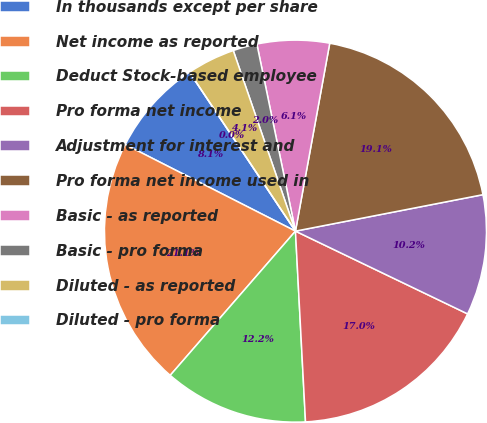<chart> <loc_0><loc_0><loc_500><loc_500><pie_chart><fcel>In thousands except per share<fcel>Net income as reported<fcel>Deduct Stock-based employee<fcel>Pro forma net income<fcel>Adjustment for interest and<fcel>Pro forma net income used in<fcel>Basic - as reported<fcel>Basic - pro forma<fcel>Diluted - as reported<fcel>Diluted - pro forma<nl><fcel>8.15%<fcel>21.11%<fcel>12.22%<fcel>17.03%<fcel>10.19%<fcel>19.07%<fcel>6.11%<fcel>2.04%<fcel>4.08%<fcel>0.0%<nl></chart> 